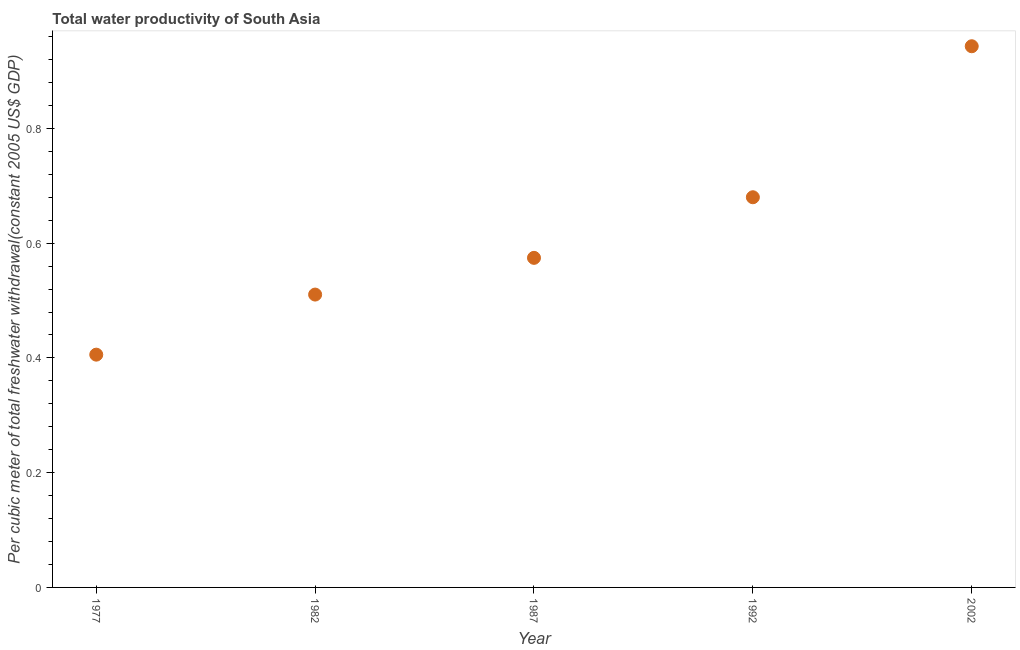What is the total water productivity in 1977?
Offer a terse response. 0.41. Across all years, what is the maximum total water productivity?
Offer a terse response. 0.94. Across all years, what is the minimum total water productivity?
Offer a terse response. 0.41. In which year was the total water productivity maximum?
Make the answer very short. 2002. What is the sum of the total water productivity?
Give a very brief answer. 3.11. What is the difference between the total water productivity in 1977 and 2002?
Make the answer very short. -0.54. What is the average total water productivity per year?
Make the answer very short. 0.62. What is the median total water productivity?
Offer a very short reply. 0.57. In how many years, is the total water productivity greater than 0.56 US$?
Provide a short and direct response. 3. What is the ratio of the total water productivity in 1987 to that in 1992?
Your answer should be very brief. 0.84. Is the difference between the total water productivity in 1987 and 2002 greater than the difference between any two years?
Your response must be concise. No. What is the difference between the highest and the second highest total water productivity?
Provide a short and direct response. 0.26. What is the difference between the highest and the lowest total water productivity?
Provide a short and direct response. 0.54. In how many years, is the total water productivity greater than the average total water productivity taken over all years?
Give a very brief answer. 2. How many years are there in the graph?
Give a very brief answer. 5. Are the values on the major ticks of Y-axis written in scientific E-notation?
Your answer should be compact. No. Does the graph contain any zero values?
Make the answer very short. No. Does the graph contain grids?
Give a very brief answer. No. What is the title of the graph?
Ensure brevity in your answer.  Total water productivity of South Asia. What is the label or title of the X-axis?
Keep it short and to the point. Year. What is the label or title of the Y-axis?
Provide a short and direct response. Per cubic meter of total freshwater withdrawal(constant 2005 US$ GDP). What is the Per cubic meter of total freshwater withdrawal(constant 2005 US$ GDP) in 1977?
Offer a terse response. 0.41. What is the Per cubic meter of total freshwater withdrawal(constant 2005 US$ GDP) in 1982?
Give a very brief answer. 0.51. What is the Per cubic meter of total freshwater withdrawal(constant 2005 US$ GDP) in 1987?
Offer a very short reply. 0.57. What is the Per cubic meter of total freshwater withdrawal(constant 2005 US$ GDP) in 1992?
Make the answer very short. 0.68. What is the Per cubic meter of total freshwater withdrawal(constant 2005 US$ GDP) in 2002?
Provide a short and direct response. 0.94. What is the difference between the Per cubic meter of total freshwater withdrawal(constant 2005 US$ GDP) in 1977 and 1982?
Your response must be concise. -0.1. What is the difference between the Per cubic meter of total freshwater withdrawal(constant 2005 US$ GDP) in 1977 and 1987?
Provide a succinct answer. -0.17. What is the difference between the Per cubic meter of total freshwater withdrawal(constant 2005 US$ GDP) in 1977 and 1992?
Keep it short and to the point. -0.27. What is the difference between the Per cubic meter of total freshwater withdrawal(constant 2005 US$ GDP) in 1977 and 2002?
Provide a short and direct response. -0.54. What is the difference between the Per cubic meter of total freshwater withdrawal(constant 2005 US$ GDP) in 1982 and 1987?
Your response must be concise. -0.06. What is the difference between the Per cubic meter of total freshwater withdrawal(constant 2005 US$ GDP) in 1982 and 1992?
Offer a very short reply. -0.17. What is the difference between the Per cubic meter of total freshwater withdrawal(constant 2005 US$ GDP) in 1982 and 2002?
Provide a short and direct response. -0.43. What is the difference between the Per cubic meter of total freshwater withdrawal(constant 2005 US$ GDP) in 1987 and 1992?
Ensure brevity in your answer.  -0.11. What is the difference between the Per cubic meter of total freshwater withdrawal(constant 2005 US$ GDP) in 1987 and 2002?
Provide a short and direct response. -0.37. What is the difference between the Per cubic meter of total freshwater withdrawal(constant 2005 US$ GDP) in 1992 and 2002?
Give a very brief answer. -0.26. What is the ratio of the Per cubic meter of total freshwater withdrawal(constant 2005 US$ GDP) in 1977 to that in 1982?
Give a very brief answer. 0.8. What is the ratio of the Per cubic meter of total freshwater withdrawal(constant 2005 US$ GDP) in 1977 to that in 1987?
Provide a succinct answer. 0.71. What is the ratio of the Per cubic meter of total freshwater withdrawal(constant 2005 US$ GDP) in 1977 to that in 1992?
Ensure brevity in your answer.  0.6. What is the ratio of the Per cubic meter of total freshwater withdrawal(constant 2005 US$ GDP) in 1977 to that in 2002?
Make the answer very short. 0.43. What is the ratio of the Per cubic meter of total freshwater withdrawal(constant 2005 US$ GDP) in 1982 to that in 1987?
Your response must be concise. 0.89. What is the ratio of the Per cubic meter of total freshwater withdrawal(constant 2005 US$ GDP) in 1982 to that in 1992?
Give a very brief answer. 0.75. What is the ratio of the Per cubic meter of total freshwater withdrawal(constant 2005 US$ GDP) in 1982 to that in 2002?
Your response must be concise. 0.54. What is the ratio of the Per cubic meter of total freshwater withdrawal(constant 2005 US$ GDP) in 1987 to that in 1992?
Make the answer very short. 0.84. What is the ratio of the Per cubic meter of total freshwater withdrawal(constant 2005 US$ GDP) in 1987 to that in 2002?
Provide a succinct answer. 0.61. What is the ratio of the Per cubic meter of total freshwater withdrawal(constant 2005 US$ GDP) in 1992 to that in 2002?
Make the answer very short. 0.72. 